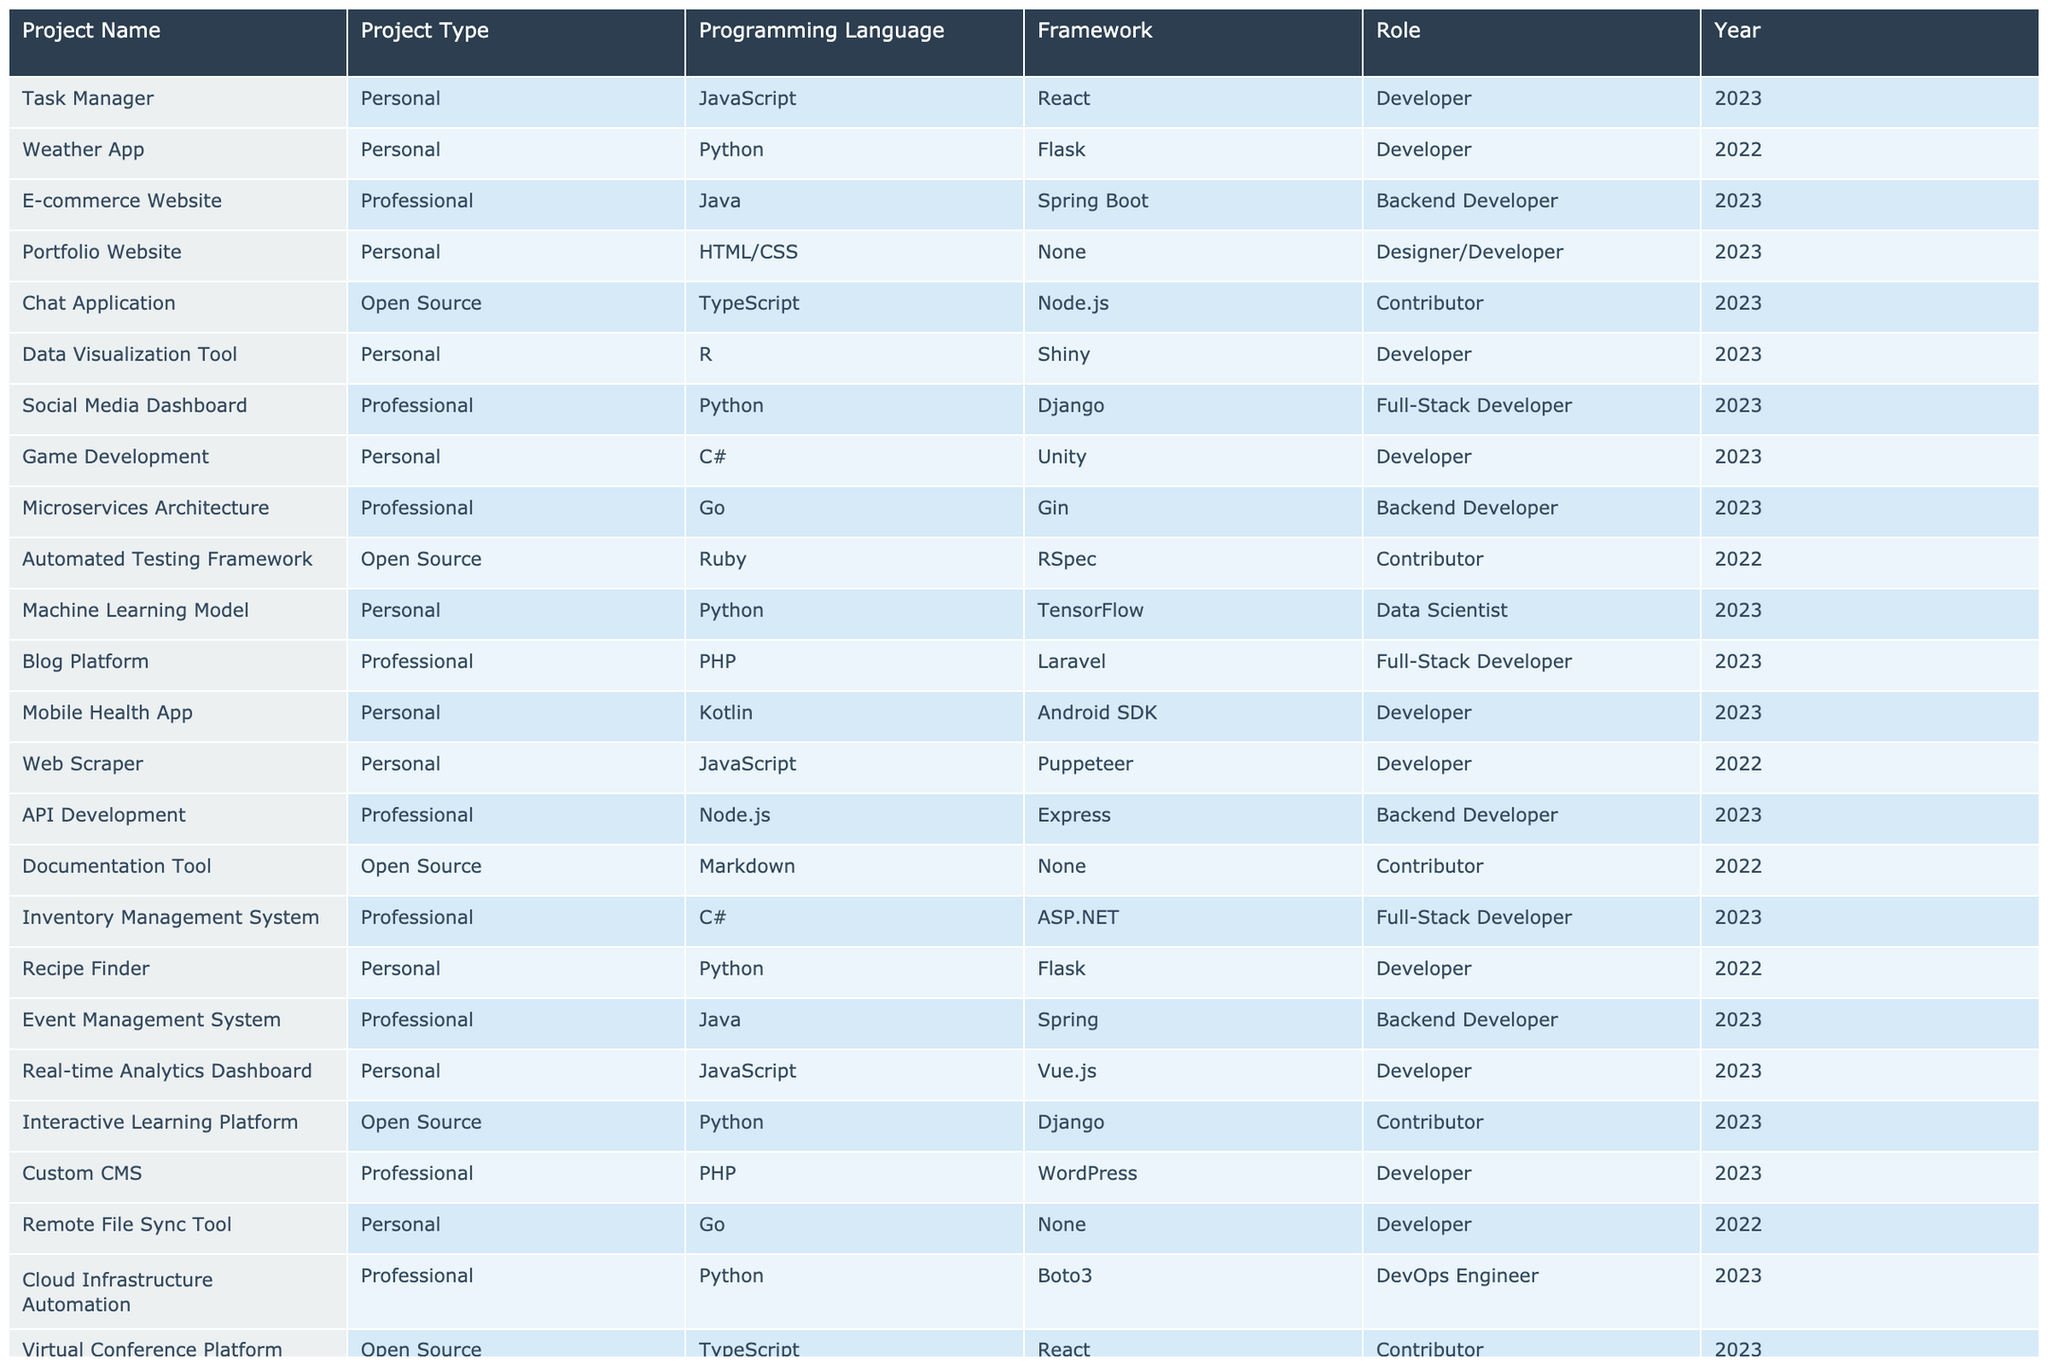What is the programming language used in the "Portfolio Website" project? The "Portfolio Website" project entry in the table lists "HTML/CSS" as the programming language.
Answer: HTML/CSS Which frameworks were used in projects that took place in 2023? By reviewing the entries for 2023, the frameworks mentioned are React, Flask, Spring Boot, Django, TensorFlow, Android SDK, Vue.js, Boto3, and others.
Answer: React, Flask, Spring Boot, Django, TensorFlow, Android SDK, Vue.js, Boto3 How many projects used Python as the programming language? Observing the table, there are four Python entries: "Weather App," "Social Media Dashboard," "Machine Learning Model," and "Recipe Finder."
Answer: 4 Is there a project using both JavaScript and a framework in 2022? Checking the table, the "Web Scraper" project is the only one listed under JavaScript, and it uses Puppeteer as a framework, which confirms the fact.
Answer: Yes What is the most recent year a project using C# was created? The table indicates two entries for C#: one for "Game Development" in 2023 and another for "Inventory Management System." Since both are in 2023, it shows C# was used recently in that year.
Answer: 2023 Which project had the role of "Data Scientist"? Looking through the table, the "Machine Learning Model" project specifically states the role of "Data Scientist" for that entry.
Answer: Machine Learning Model Count the total number of personal projects listed in the table. By examining the table, there are ten entries marked as "Personal." Thus, the total count is ten projects.
Answer: 10 Which framework was used in the "E-commerce Website" project and by what role? The "E-commerce Website" uses "Spring Boot" as its framework and the role listed is "Backend Developer."
Answer: Spring Boot, Backend Developer How many open-source projects are running on TypeScript? The table reveals two projects using TypeScript: the "Chat Application" and the "Virtual Conference Platform," which totals to two projects.
Answer: 2 Did any project use the Go programming language and what is the project name? Yes, there are projects using Go: the "Microservices Architecture" and "Remote File Sync Tool." The first one is the most recent project under Go.
Answer: Microservices Architecture 